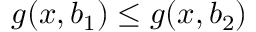<formula> <loc_0><loc_0><loc_500><loc_500>g ( x , b _ { 1 } ) \leq g ( x , b _ { 2 } )</formula> 